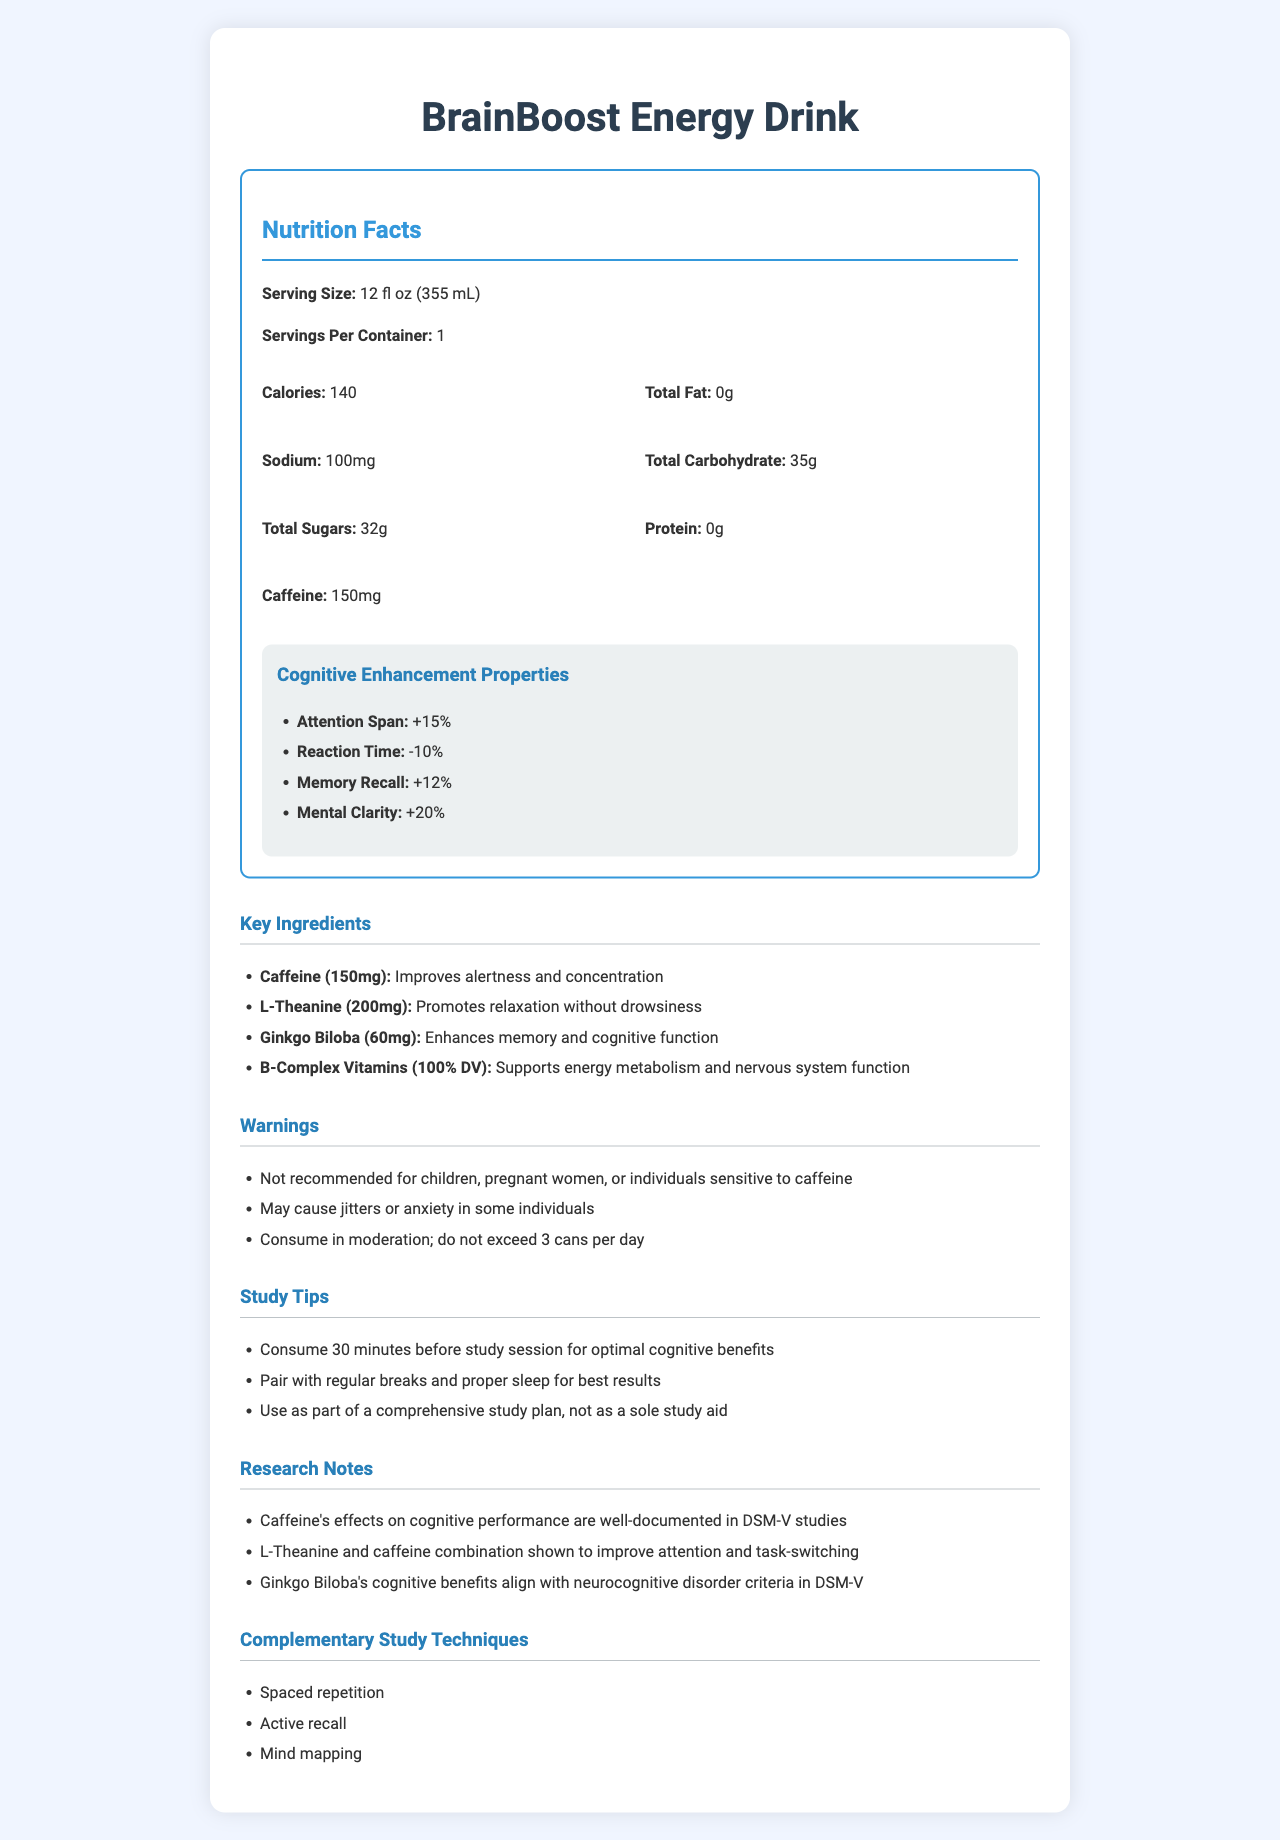what is the serving size of BrainBoost Energy Drink? The serving size is listed near the top section under Nutrition Facts.
Answer: 12 fl oz (355 mL) how many calories are there per serving? The calories are specified in the nutrition facts section of the document.
Answer: 140 which ingredient in BrainBoost Energy Drink enhances memory and cognitive function? The document lists Ginkgo Biloba as enhancing memory and cognitive function in the key ingredients section.
Answer: Ginkgo Biloba what is the main warning for individuals sensitive to caffeine? This warning is listed under the warnings section.
Answer: Not recommended for children, pregnant women, or individuals sensitive to caffeine what is the percentage increase in attention span provided by the drink? The percentage increase in attention span is listed under cognitive enhancement properties.
Answer: +15% how much sodium is in BrainBoost Energy Drink? Sodium content is specified in the Nutrition Facts section.
Answer: 100mg which key ingredient has a dosage of 200mg? The dosage information is listed under the key ingredients section.
Answer: L-Theanine what percentage of Daily Value (DV) for B-Complex Vitamins does BrainBoost Energy Drink provide? The B-Complex Vitamins dosage is specified as 100% DV in the key ingredients section.
Answer: 100% when should you consume this drink for optimal cognitive benefits during a study session? This advice is noted in the study tips section.
Answer: 30 minutes before study session True or False: BrainBoost Energy Drink contains protein. The document's nutrition facts section states there is 0g of protein.
Answer: False summarize the main components of the BrainBoost Energy Drink document. The document starts with nutritional facts, then lists cognitive benefits, ingredients, warnings, study advice, research notes, and additional study methods.
Answer: The document provides detailed information about BrainBoost Energy Drink, including its nutritional contents, cognitive enhancement properties, key ingredients, warnings, study tips, research notes, and recommended complementary study techniques. which of the following effects is not listed as a cognitive enhancement property of BrainBoost Energy Drink? A. Attention span B. Reaction time C. Problem-solving ability D. Memory recall The listed properties are attention span, reaction time, memory recall, and mental clarity. Problem-solving ability is not mentioned.
Answer: C. Problem-solving ability what should you pair with the beverage for best results according to study tips? A. Regular breaks B. Proper sleep C. Both A and B D. Neither A nor B The study tips section advises pairing the beverage with regular breaks and proper sleep for best results.
Answer: C. Both A and B how does the combination of L-Theanine and caffeine affect cognitive performance according to the research notes? The combination of L-Theanine and caffeine is documented to improve attention and task-switching in the research notes section.
Answer: Improves attention and task-switching what complementary study techniques are recommended with BrainBoost Energy Drink? These techniques are listed in the complementary study techniques section.
Answer: Spaced repetition, active recall, mind mapping how many cans of BrainBoost Energy Drink should you not exceed per day? The warning section advises not to exceed 3 cans per day.
Answer: 3 cans how does caffeine's effect on cognitive performance relate to DSM-V? This information is provided in the research notes section.
Answer: Caffeine's effects on cognitive performance are well-documented in DSM-V studies. in the research notes, which cognitive benefit aligns with neurocognitive disorder criteria in DSM-V? The research notes mention that Ginkgo Biloba’s cognitive benefits align with neurocognitive disorder criteria in DSM-V.
Answer: Ginkgo Biloba's cognitive benefits what is the exact amount of total sugars in the BrainBoost Energy Drink? The total sugar content is clearly specified in the Nutrition Facts section.
Answer: 32g how does the BrainBoost Energy Drink affect mental clarity? The cognitive enhancement properties section lists an increase of +20% in mental clarity.
Answer: +20% are the total carbohydrates in the drink more than 30g? The total carbohydrates are listed as 35g, which is more than 30g.
Answer: Yes what is the effect of consuming more than 3 cans of BrainBoost Energy Drink per day? The document advises not exceeding 3 cans per day but does not specify the effects of overconsumption.
Answer: Not mentioned 